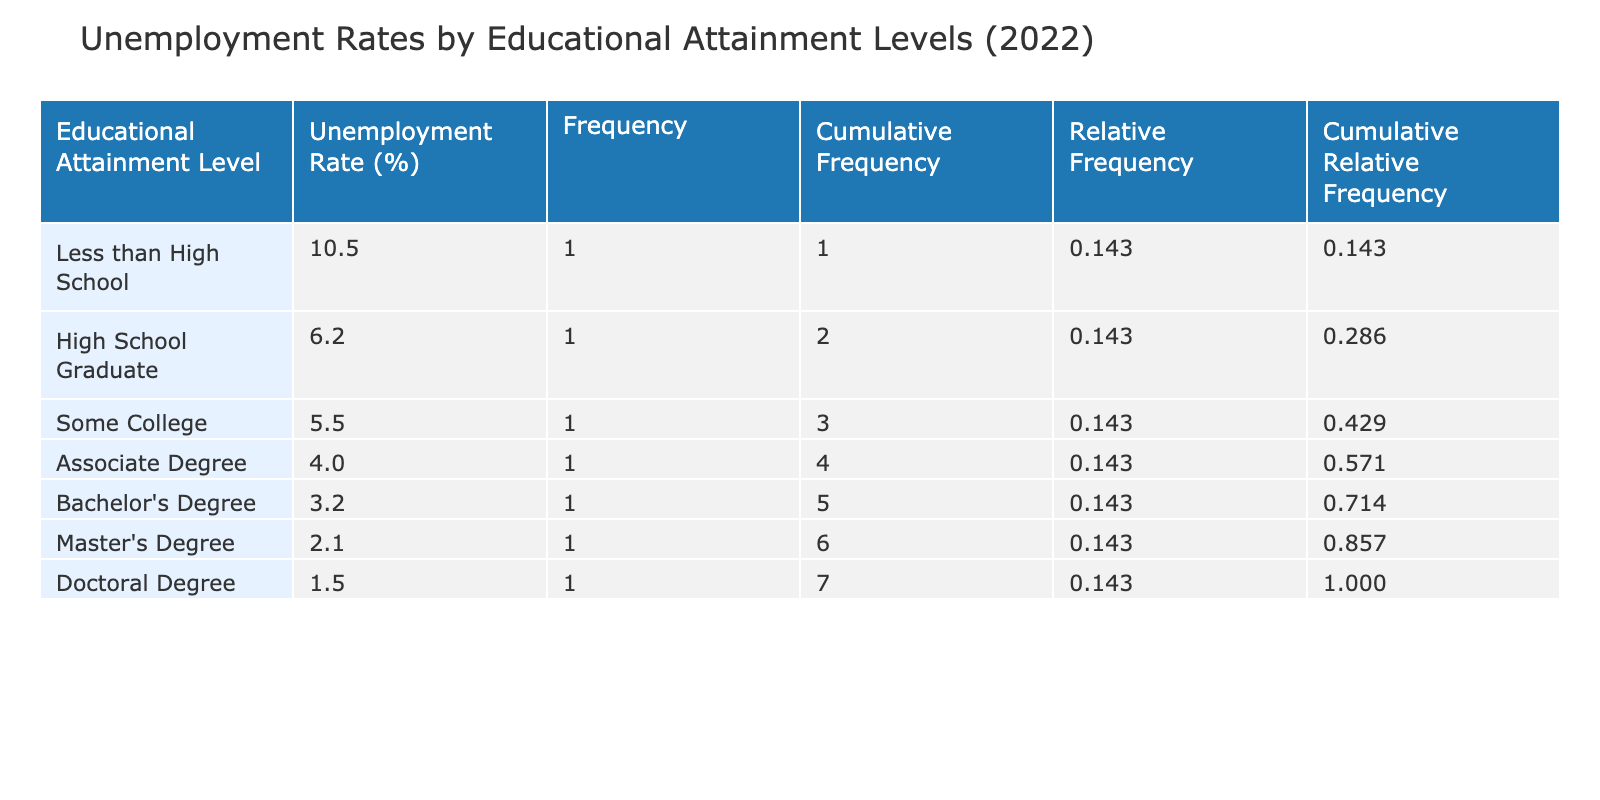What is the unemployment rate for someone with a Bachelor's Degree? According to the table, the unemployment rate for individuals with a Bachelor's Degree is listed directly under that category, which shows it is 3.2%.
Answer: 3.2% What educational attainment level has the highest unemployment rate? By examining the table, we find that "Less than High School" has the highest unemployment rate at 10.5%.
Answer: Less than High School What is the difference in unemployment rates between those with a Doctoral Degree and those who are High School Graduates? The unemployment rate for Doctoral Degree holders is 1.5%, and for High School Graduates, it is 6.2%. The difference is calculated as 6.2% - 1.5% = 4.7%.
Answer: 4.7% Is it true that individuals with an Associate Degree have a lower unemployment rate than those with a Master's Degree? The unemployment rate for individuals with an Associate Degree is 4.0%, while for those with a Master's Degree it is 2.1%. Since 4.0% is greater than 2.1%, the statement is false.
Answer: No What is the cumulative frequency of unemployment rates for educational attainment levels at or below a High School Graduate? The cumulative frequency for High School Graduates includes the frequencies of "Less than High School" (1) and "High School Graduate" (1), resulting in 1 + 1 = 2.
Answer: 2 What percentage of individuals are expected to be unemployed if they have a degree higher than a Bachelor's Degree? The unemployment rates for Master's and Doctoral degrees are 2.1% and 1.5%, respectively. The total unemployment for these two groups is 2.1% + 1.5% = 3.6%.
Answer: 3.6% Which educational attainment level has the lowest unemployment rate? The table indicates that the educational attainment level with the lowest unemployment rate is "Doctoral Degree," at a rate of 1.5%.
Answer: Doctoral Degree What is the average unemployment rate across all education levels represented in the table? To calculate the average, we add all the unemployment rates: 10.5% + 6.2% + 5.5% + 4.0% + 3.2% + 2.1% + 1.5% = 33.0%, then divide by 7 (the number of education levels), which results in approximately 4.71%.
Answer: 4.71% 